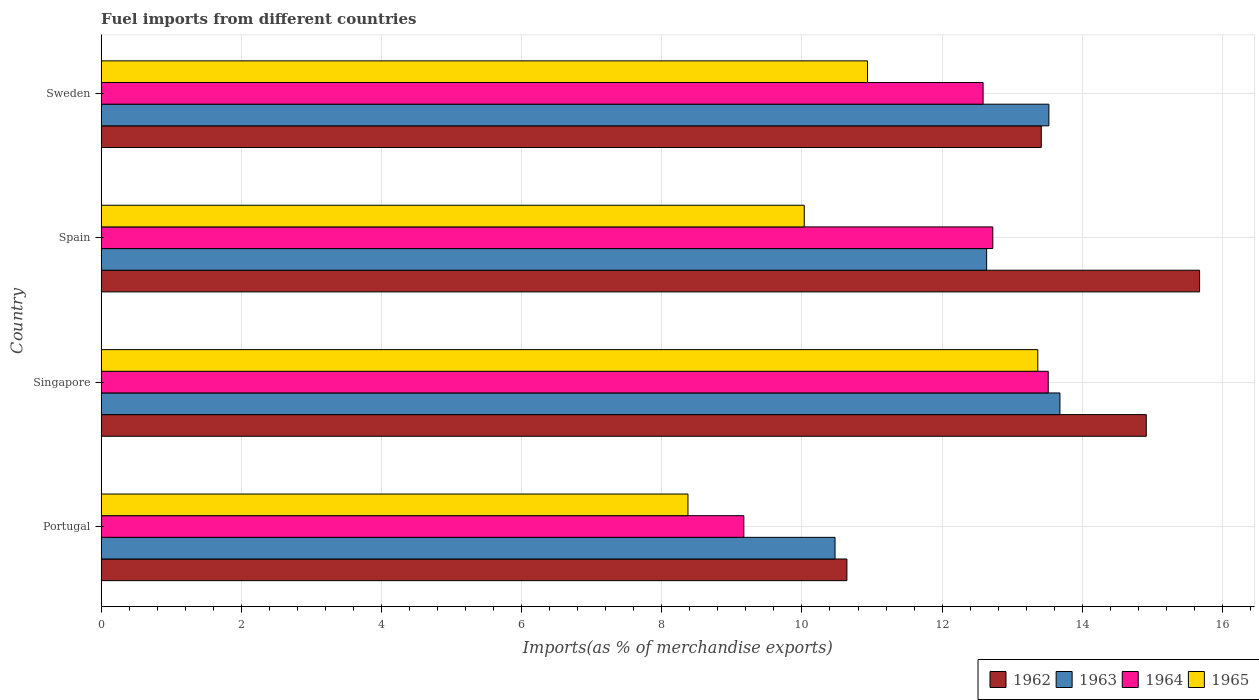What is the label of the 4th group of bars from the top?
Provide a short and direct response. Portugal. What is the percentage of imports to different countries in 1962 in Singapore?
Offer a terse response. 14.91. Across all countries, what is the maximum percentage of imports to different countries in 1962?
Give a very brief answer. 15.67. Across all countries, what is the minimum percentage of imports to different countries in 1962?
Make the answer very short. 10.64. In which country was the percentage of imports to different countries in 1963 maximum?
Ensure brevity in your answer.  Singapore. What is the total percentage of imports to different countries in 1963 in the graph?
Give a very brief answer. 50.31. What is the difference between the percentage of imports to different countries in 1962 in Portugal and that in Sweden?
Ensure brevity in your answer.  -2.77. What is the difference between the percentage of imports to different countries in 1962 in Sweden and the percentage of imports to different countries in 1963 in Spain?
Keep it short and to the point. 0.78. What is the average percentage of imports to different countries in 1962 per country?
Ensure brevity in your answer.  13.66. What is the difference between the percentage of imports to different countries in 1965 and percentage of imports to different countries in 1963 in Sweden?
Offer a terse response. -2.59. In how many countries, is the percentage of imports to different countries in 1964 greater than 10.4 %?
Give a very brief answer. 3. What is the ratio of the percentage of imports to different countries in 1963 in Portugal to that in Spain?
Ensure brevity in your answer.  0.83. Is the percentage of imports to different countries in 1964 in Singapore less than that in Spain?
Give a very brief answer. No. What is the difference between the highest and the second highest percentage of imports to different countries in 1965?
Your answer should be compact. 2.43. What is the difference between the highest and the lowest percentage of imports to different countries in 1964?
Your answer should be compact. 4.34. Is it the case that in every country, the sum of the percentage of imports to different countries in 1964 and percentage of imports to different countries in 1962 is greater than the sum of percentage of imports to different countries in 1965 and percentage of imports to different countries in 1963?
Your answer should be compact. No. What does the 4th bar from the top in Sweden represents?
Your response must be concise. 1962. What does the 1st bar from the bottom in Portugal represents?
Give a very brief answer. 1962. Is it the case that in every country, the sum of the percentage of imports to different countries in 1965 and percentage of imports to different countries in 1963 is greater than the percentage of imports to different countries in 1964?
Provide a succinct answer. Yes. Are all the bars in the graph horizontal?
Provide a short and direct response. Yes. How many countries are there in the graph?
Your answer should be compact. 4. What is the difference between two consecutive major ticks on the X-axis?
Offer a very short reply. 2. Are the values on the major ticks of X-axis written in scientific E-notation?
Your response must be concise. No. What is the title of the graph?
Offer a very short reply. Fuel imports from different countries. What is the label or title of the X-axis?
Make the answer very short. Imports(as % of merchandise exports). What is the label or title of the Y-axis?
Offer a very short reply. Country. What is the Imports(as % of merchandise exports) in 1962 in Portugal?
Your answer should be compact. 10.64. What is the Imports(as % of merchandise exports) in 1963 in Portugal?
Your answer should be very brief. 10.47. What is the Imports(as % of merchandise exports) in 1964 in Portugal?
Give a very brief answer. 9.17. What is the Imports(as % of merchandise exports) of 1965 in Portugal?
Ensure brevity in your answer.  8.37. What is the Imports(as % of merchandise exports) in 1962 in Singapore?
Give a very brief answer. 14.91. What is the Imports(as % of merchandise exports) in 1963 in Singapore?
Give a very brief answer. 13.68. What is the Imports(as % of merchandise exports) in 1964 in Singapore?
Provide a short and direct response. 13.51. What is the Imports(as % of merchandise exports) of 1965 in Singapore?
Make the answer very short. 13.37. What is the Imports(as % of merchandise exports) of 1962 in Spain?
Give a very brief answer. 15.67. What is the Imports(as % of merchandise exports) of 1963 in Spain?
Ensure brevity in your answer.  12.64. What is the Imports(as % of merchandise exports) of 1964 in Spain?
Make the answer very short. 12.72. What is the Imports(as % of merchandise exports) of 1965 in Spain?
Provide a succinct answer. 10.03. What is the Imports(as % of merchandise exports) in 1962 in Sweden?
Your response must be concise. 13.42. What is the Imports(as % of merchandise exports) of 1963 in Sweden?
Keep it short and to the point. 13.52. What is the Imports(as % of merchandise exports) of 1964 in Sweden?
Offer a terse response. 12.58. What is the Imports(as % of merchandise exports) of 1965 in Sweden?
Provide a succinct answer. 10.93. Across all countries, what is the maximum Imports(as % of merchandise exports) of 1962?
Offer a very short reply. 15.67. Across all countries, what is the maximum Imports(as % of merchandise exports) of 1963?
Provide a short and direct response. 13.68. Across all countries, what is the maximum Imports(as % of merchandise exports) of 1964?
Offer a very short reply. 13.51. Across all countries, what is the maximum Imports(as % of merchandise exports) in 1965?
Make the answer very short. 13.37. Across all countries, what is the minimum Imports(as % of merchandise exports) in 1962?
Provide a short and direct response. 10.64. Across all countries, what is the minimum Imports(as % of merchandise exports) of 1963?
Provide a succinct answer. 10.47. Across all countries, what is the minimum Imports(as % of merchandise exports) of 1964?
Keep it short and to the point. 9.17. Across all countries, what is the minimum Imports(as % of merchandise exports) in 1965?
Your answer should be very brief. 8.37. What is the total Imports(as % of merchandise exports) in 1962 in the graph?
Your answer should be very brief. 54.64. What is the total Imports(as % of merchandise exports) of 1963 in the graph?
Your answer should be compact. 50.31. What is the total Imports(as % of merchandise exports) in 1964 in the graph?
Keep it short and to the point. 47.99. What is the total Imports(as % of merchandise exports) in 1965 in the graph?
Keep it short and to the point. 42.71. What is the difference between the Imports(as % of merchandise exports) of 1962 in Portugal and that in Singapore?
Keep it short and to the point. -4.27. What is the difference between the Imports(as % of merchandise exports) in 1963 in Portugal and that in Singapore?
Your answer should be very brief. -3.21. What is the difference between the Imports(as % of merchandise exports) of 1964 in Portugal and that in Singapore?
Offer a very short reply. -4.34. What is the difference between the Imports(as % of merchandise exports) in 1965 in Portugal and that in Singapore?
Give a very brief answer. -4.99. What is the difference between the Imports(as % of merchandise exports) in 1962 in Portugal and that in Spain?
Your answer should be compact. -5.03. What is the difference between the Imports(as % of merchandise exports) of 1963 in Portugal and that in Spain?
Your response must be concise. -2.16. What is the difference between the Imports(as % of merchandise exports) in 1964 in Portugal and that in Spain?
Make the answer very short. -3.55. What is the difference between the Imports(as % of merchandise exports) in 1965 in Portugal and that in Spain?
Your answer should be very brief. -1.66. What is the difference between the Imports(as % of merchandise exports) in 1962 in Portugal and that in Sweden?
Provide a short and direct response. -2.77. What is the difference between the Imports(as % of merchandise exports) of 1963 in Portugal and that in Sweden?
Offer a terse response. -3.05. What is the difference between the Imports(as % of merchandise exports) of 1964 in Portugal and that in Sweden?
Offer a very short reply. -3.41. What is the difference between the Imports(as % of merchandise exports) of 1965 in Portugal and that in Sweden?
Offer a terse response. -2.56. What is the difference between the Imports(as % of merchandise exports) in 1962 in Singapore and that in Spain?
Give a very brief answer. -0.76. What is the difference between the Imports(as % of merchandise exports) in 1963 in Singapore and that in Spain?
Offer a very short reply. 1.05. What is the difference between the Imports(as % of merchandise exports) of 1964 in Singapore and that in Spain?
Provide a succinct answer. 0.79. What is the difference between the Imports(as % of merchandise exports) in 1965 in Singapore and that in Spain?
Provide a short and direct response. 3.33. What is the difference between the Imports(as % of merchandise exports) of 1962 in Singapore and that in Sweden?
Make the answer very short. 1.5. What is the difference between the Imports(as % of merchandise exports) of 1963 in Singapore and that in Sweden?
Provide a short and direct response. 0.16. What is the difference between the Imports(as % of merchandise exports) in 1964 in Singapore and that in Sweden?
Give a very brief answer. 0.93. What is the difference between the Imports(as % of merchandise exports) in 1965 in Singapore and that in Sweden?
Your answer should be very brief. 2.43. What is the difference between the Imports(as % of merchandise exports) in 1962 in Spain and that in Sweden?
Offer a terse response. 2.26. What is the difference between the Imports(as % of merchandise exports) of 1963 in Spain and that in Sweden?
Provide a succinct answer. -0.89. What is the difference between the Imports(as % of merchandise exports) of 1964 in Spain and that in Sweden?
Your answer should be compact. 0.14. What is the difference between the Imports(as % of merchandise exports) in 1965 in Spain and that in Sweden?
Provide a short and direct response. -0.9. What is the difference between the Imports(as % of merchandise exports) in 1962 in Portugal and the Imports(as % of merchandise exports) in 1963 in Singapore?
Keep it short and to the point. -3.04. What is the difference between the Imports(as % of merchandise exports) of 1962 in Portugal and the Imports(as % of merchandise exports) of 1964 in Singapore?
Ensure brevity in your answer.  -2.87. What is the difference between the Imports(as % of merchandise exports) of 1962 in Portugal and the Imports(as % of merchandise exports) of 1965 in Singapore?
Offer a very short reply. -2.72. What is the difference between the Imports(as % of merchandise exports) of 1963 in Portugal and the Imports(as % of merchandise exports) of 1964 in Singapore?
Give a very brief answer. -3.04. What is the difference between the Imports(as % of merchandise exports) of 1963 in Portugal and the Imports(as % of merchandise exports) of 1965 in Singapore?
Make the answer very short. -2.89. What is the difference between the Imports(as % of merchandise exports) in 1964 in Portugal and the Imports(as % of merchandise exports) in 1965 in Singapore?
Provide a short and direct response. -4.19. What is the difference between the Imports(as % of merchandise exports) in 1962 in Portugal and the Imports(as % of merchandise exports) in 1963 in Spain?
Your answer should be compact. -1.99. What is the difference between the Imports(as % of merchandise exports) in 1962 in Portugal and the Imports(as % of merchandise exports) in 1964 in Spain?
Your response must be concise. -2.08. What is the difference between the Imports(as % of merchandise exports) in 1962 in Portugal and the Imports(as % of merchandise exports) in 1965 in Spain?
Your answer should be compact. 0.61. What is the difference between the Imports(as % of merchandise exports) of 1963 in Portugal and the Imports(as % of merchandise exports) of 1964 in Spain?
Provide a short and direct response. -2.25. What is the difference between the Imports(as % of merchandise exports) in 1963 in Portugal and the Imports(as % of merchandise exports) in 1965 in Spain?
Your answer should be very brief. 0.44. What is the difference between the Imports(as % of merchandise exports) of 1964 in Portugal and the Imports(as % of merchandise exports) of 1965 in Spain?
Offer a terse response. -0.86. What is the difference between the Imports(as % of merchandise exports) in 1962 in Portugal and the Imports(as % of merchandise exports) in 1963 in Sweden?
Ensure brevity in your answer.  -2.88. What is the difference between the Imports(as % of merchandise exports) in 1962 in Portugal and the Imports(as % of merchandise exports) in 1964 in Sweden?
Your answer should be very brief. -1.94. What is the difference between the Imports(as % of merchandise exports) in 1962 in Portugal and the Imports(as % of merchandise exports) in 1965 in Sweden?
Give a very brief answer. -0.29. What is the difference between the Imports(as % of merchandise exports) of 1963 in Portugal and the Imports(as % of merchandise exports) of 1964 in Sweden?
Your answer should be very brief. -2.11. What is the difference between the Imports(as % of merchandise exports) of 1963 in Portugal and the Imports(as % of merchandise exports) of 1965 in Sweden?
Your answer should be very brief. -0.46. What is the difference between the Imports(as % of merchandise exports) of 1964 in Portugal and the Imports(as % of merchandise exports) of 1965 in Sweden?
Give a very brief answer. -1.76. What is the difference between the Imports(as % of merchandise exports) of 1962 in Singapore and the Imports(as % of merchandise exports) of 1963 in Spain?
Your answer should be compact. 2.28. What is the difference between the Imports(as % of merchandise exports) of 1962 in Singapore and the Imports(as % of merchandise exports) of 1964 in Spain?
Offer a terse response. 2.19. What is the difference between the Imports(as % of merchandise exports) in 1962 in Singapore and the Imports(as % of merchandise exports) in 1965 in Spain?
Your response must be concise. 4.88. What is the difference between the Imports(as % of merchandise exports) of 1963 in Singapore and the Imports(as % of merchandise exports) of 1964 in Spain?
Provide a succinct answer. 0.96. What is the difference between the Imports(as % of merchandise exports) in 1963 in Singapore and the Imports(as % of merchandise exports) in 1965 in Spain?
Make the answer very short. 3.65. What is the difference between the Imports(as % of merchandise exports) in 1964 in Singapore and the Imports(as % of merchandise exports) in 1965 in Spain?
Keep it short and to the point. 3.48. What is the difference between the Imports(as % of merchandise exports) in 1962 in Singapore and the Imports(as % of merchandise exports) in 1963 in Sweden?
Make the answer very short. 1.39. What is the difference between the Imports(as % of merchandise exports) in 1962 in Singapore and the Imports(as % of merchandise exports) in 1964 in Sweden?
Your response must be concise. 2.33. What is the difference between the Imports(as % of merchandise exports) of 1962 in Singapore and the Imports(as % of merchandise exports) of 1965 in Sweden?
Ensure brevity in your answer.  3.98. What is the difference between the Imports(as % of merchandise exports) of 1963 in Singapore and the Imports(as % of merchandise exports) of 1964 in Sweden?
Provide a short and direct response. 1.1. What is the difference between the Imports(as % of merchandise exports) in 1963 in Singapore and the Imports(as % of merchandise exports) in 1965 in Sweden?
Provide a short and direct response. 2.75. What is the difference between the Imports(as % of merchandise exports) of 1964 in Singapore and the Imports(as % of merchandise exports) of 1965 in Sweden?
Make the answer very short. 2.58. What is the difference between the Imports(as % of merchandise exports) in 1962 in Spain and the Imports(as % of merchandise exports) in 1963 in Sweden?
Offer a terse response. 2.15. What is the difference between the Imports(as % of merchandise exports) of 1962 in Spain and the Imports(as % of merchandise exports) of 1964 in Sweden?
Ensure brevity in your answer.  3.09. What is the difference between the Imports(as % of merchandise exports) in 1962 in Spain and the Imports(as % of merchandise exports) in 1965 in Sweden?
Provide a succinct answer. 4.74. What is the difference between the Imports(as % of merchandise exports) of 1963 in Spain and the Imports(as % of merchandise exports) of 1964 in Sweden?
Give a very brief answer. 0.05. What is the difference between the Imports(as % of merchandise exports) in 1963 in Spain and the Imports(as % of merchandise exports) in 1965 in Sweden?
Make the answer very short. 1.7. What is the difference between the Imports(as % of merchandise exports) of 1964 in Spain and the Imports(as % of merchandise exports) of 1965 in Sweden?
Your answer should be compact. 1.79. What is the average Imports(as % of merchandise exports) in 1962 per country?
Provide a short and direct response. 13.66. What is the average Imports(as % of merchandise exports) in 1963 per country?
Provide a succinct answer. 12.58. What is the average Imports(as % of merchandise exports) in 1964 per country?
Offer a very short reply. 12. What is the average Imports(as % of merchandise exports) of 1965 per country?
Offer a very short reply. 10.68. What is the difference between the Imports(as % of merchandise exports) of 1962 and Imports(as % of merchandise exports) of 1963 in Portugal?
Offer a very short reply. 0.17. What is the difference between the Imports(as % of merchandise exports) of 1962 and Imports(as % of merchandise exports) of 1964 in Portugal?
Give a very brief answer. 1.47. What is the difference between the Imports(as % of merchandise exports) of 1962 and Imports(as % of merchandise exports) of 1965 in Portugal?
Give a very brief answer. 2.27. What is the difference between the Imports(as % of merchandise exports) in 1963 and Imports(as % of merchandise exports) in 1964 in Portugal?
Ensure brevity in your answer.  1.3. What is the difference between the Imports(as % of merchandise exports) in 1963 and Imports(as % of merchandise exports) in 1965 in Portugal?
Provide a short and direct response. 2.1. What is the difference between the Imports(as % of merchandise exports) in 1964 and Imports(as % of merchandise exports) in 1965 in Portugal?
Keep it short and to the point. 0.8. What is the difference between the Imports(as % of merchandise exports) of 1962 and Imports(as % of merchandise exports) of 1963 in Singapore?
Your answer should be compact. 1.23. What is the difference between the Imports(as % of merchandise exports) of 1962 and Imports(as % of merchandise exports) of 1964 in Singapore?
Give a very brief answer. 1.4. What is the difference between the Imports(as % of merchandise exports) in 1962 and Imports(as % of merchandise exports) in 1965 in Singapore?
Your answer should be compact. 1.55. What is the difference between the Imports(as % of merchandise exports) in 1963 and Imports(as % of merchandise exports) in 1964 in Singapore?
Give a very brief answer. 0.17. What is the difference between the Imports(as % of merchandise exports) of 1963 and Imports(as % of merchandise exports) of 1965 in Singapore?
Give a very brief answer. 0.32. What is the difference between the Imports(as % of merchandise exports) of 1964 and Imports(as % of merchandise exports) of 1965 in Singapore?
Make the answer very short. 0.15. What is the difference between the Imports(as % of merchandise exports) in 1962 and Imports(as % of merchandise exports) in 1963 in Spain?
Offer a very short reply. 3.04. What is the difference between the Imports(as % of merchandise exports) of 1962 and Imports(as % of merchandise exports) of 1964 in Spain?
Give a very brief answer. 2.95. What is the difference between the Imports(as % of merchandise exports) of 1962 and Imports(as % of merchandise exports) of 1965 in Spain?
Make the answer very short. 5.64. What is the difference between the Imports(as % of merchandise exports) of 1963 and Imports(as % of merchandise exports) of 1964 in Spain?
Offer a very short reply. -0.09. What is the difference between the Imports(as % of merchandise exports) in 1963 and Imports(as % of merchandise exports) in 1965 in Spain?
Make the answer very short. 2.6. What is the difference between the Imports(as % of merchandise exports) in 1964 and Imports(as % of merchandise exports) in 1965 in Spain?
Your answer should be compact. 2.69. What is the difference between the Imports(as % of merchandise exports) in 1962 and Imports(as % of merchandise exports) in 1963 in Sweden?
Offer a very short reply. -0.11. What is the difference between the Imports(as % of merchandise exports) of 1962 and Imports(as % of merchandise exports) of 1964 in Sweden?
Offer a terse response. 0.83. What is the difference between the Imports(as % of merchandise exports) of 1962 and Imports(as % of merchandise exports) of 1965 in Sweden?
Your response must be concise. 2.48. What is the difference between the Imports(as % of merchandise exports) of 1963 and Imports(as % of merchandise exports) of 1964 in Sweden?
Ensure brevity in your answer.  0.94. What is the difference between the Imports(as % of merchandise exports) of 1963 and Imports(as % of merchandise exports) of 1965 in Sweden?
Provide a succinct answer. 2.59. What is the difference between the Imports(as % of merchandise exports) in 1964 and Imports(as % of merchandise exports) in 1965 in Sweden?
Your response must be concise. 1.65. What is the ratio of the Imports(as % of merchandise exports) of 1962 in Portugal to that in Singapore?
Give a very brief answer. 0.71. What is the ratio of the Imports(as % of merchandise exports) in 1963 in Portugal to that in Singapore?
Offer a terse response. 0.77. What is the ratio of the Imports(as % of merchandise exports) of 1964 in Portugal to that in Singapore?
Your answer should be very brief. 0.68. What is the ratio of the Imports(as % of merchandise exports) in 1965 in Portugal to that in Singapore?
Provide a short and direct response. 0.63. What is the ratio of the Imports(as % of merchandise exports) of 1962 in Portugal to that in Spain?
Make the answer very short. 0.68. What is the ratio of the Imports(as % of merchandise exports) of 1963 in Portugal to that in Spain?
Make the answer very short. 0.83. What is the ratio of the Imports(as % of merchandise exports) of 1964 in Portugal to that in Spain?
Your answer should be compact. 0.72. What is the ratio of the Imports(as % of merchandise exports) in 1965 in Portugal to that in Spain?
Give a very brief answer. 0.83. What is the ratio of the Imports(as % of merchandise exports) in 1962 in Portugal to that in Sweden?
Your answer should be compact. 0.79. What is the ratio of the Imports(as % of merchandise exports) of 1963 in Portugal to that in Sweden?
Give a very brief answer. 0.77. What is the ratio of the Imports(as % of merchandise exports) of 1964 in Portugal to that in Sweden?
Your response must be concise. 0.73. What is the ratio of the Imports(as % of merchandise exports) in 1965 in Portugal to that in Sweden?
Your answer should be compact. 0.77. What is the ratio of the Imports(as % of merchandise exports) in 1962 in Singapore to that in Spain?
Give a very brief answer. 0.95. What is the ratio of the Imports(as % of merchandise exports) of 1963 in Singapore to that in Spain?
Offer a very short reply. 1.08. What is the ratio of the Imports(as % of merchandise exports) in 1964 in Singapore to that in Spain?
Your response must be concise. 1.06. What is the ratio of the Imports(as % of merchandise exports) of 1965 in Singapore to that in Spain?
Make the answer very short. 1.33. What is the ratio of the Imports(as % of merchandise exports) in 1962 in Singapore to that in Sweden?
Keep it short and to the point. 1.11. What is the ratio of the Imports(as % of merchandise exports) of 1963 in Singapore to that in Sweden?
Provide a short and direct response. 1.01. What is the ratio of the Imports(as % of merchandise exports) in 1964 in Singapore to that in Sweden?
Offer a terse response. 1.07. What is the ratio of the Imports(as % of merchandise exports) in 1965 in Singapore to that in Sweden?
Provide a succinct answer. 1.22. What is the ratio of the Imports(as % of merchandise exports) in 1962 in Spain to that in Sweden?
Keep it short and to the point. 1.17. What is the ratio of the Imports(as % of merchandise exports) in 1963 in Spain to that in Sweden?
Give a very brief answer. 0.93. What is the ratio of the Imports(as % of merchandise exports) in 1965 in Spain to that in Sweden?
Your answer should be compact. 0.92. What is the difference between the highest and the second highest Imports(as % of merchandise exports) in 1962?
Your answer should be compact. 0.76. What is the difference between the highest and the second highest Imports(as % of merchandise exports) of 1963?
Ensure brevity in your answer.  0.16. What is the difference between the highest and the second highest Imports(as % of merchandise exports) in 1964?
Your answer should be very brief. 0.79. What is the difference between the highest and the second highest Imports(as % of merchandise exports) of 1965?
Offer a very short reply. 2.43. What is the difference between the highest and the lowest Imports(as % of merchandise exports) in 1962?
Your response must be concise. 5.03. What is the difference between the highest and the lowest Imports(as % of merchandise exports) of 1963?
Keep it short and to the point. 3.21. What is the difference between the highest and the lowest Imports(as % of merchandise exports) in 1964?
Offer a very short reply. 4.34. What is the difference between the highest and the lowest Imports(as % of merchandise exports) in 1965?
Provide a succinct answer. 4.99. 